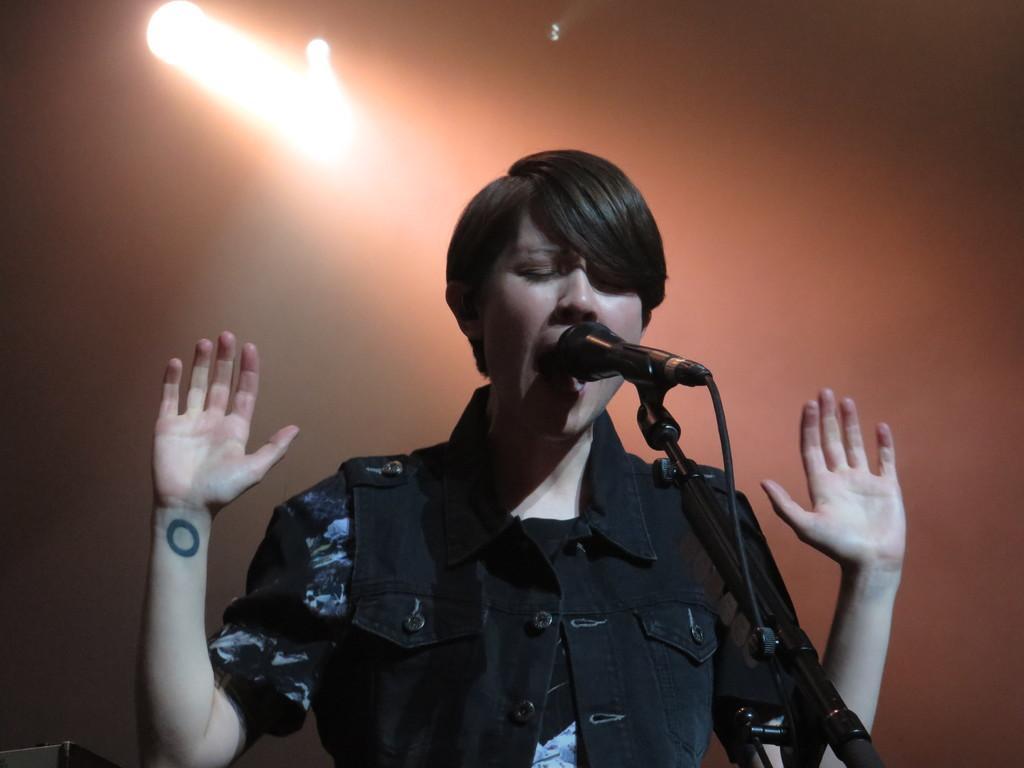Please provide a concise description of this image. In this image there is a person singing into a mic in front of him with cable, at the top of the image there are focus lights. 